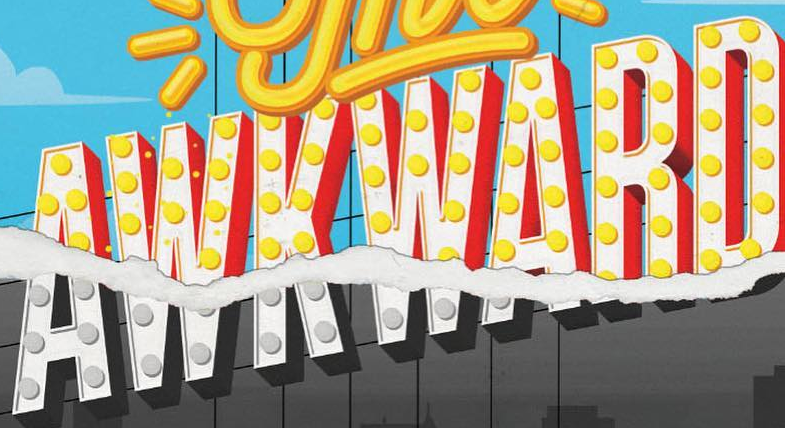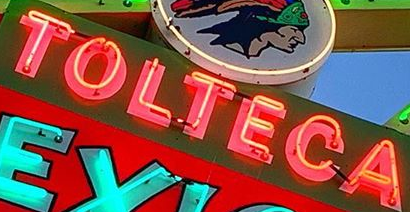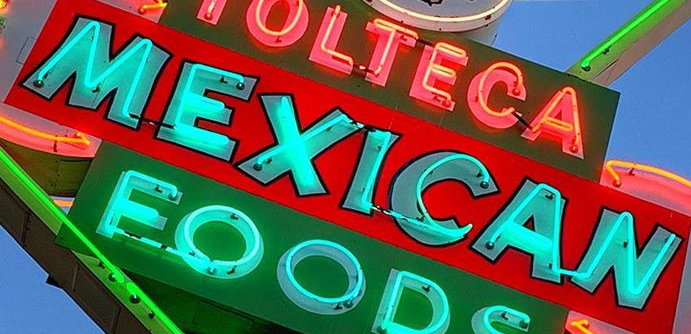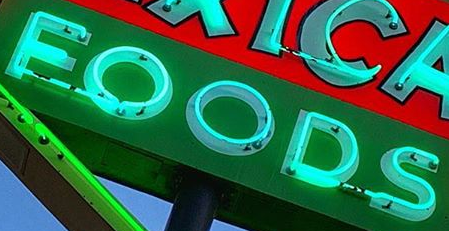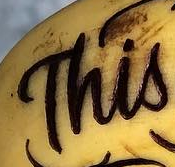What words are shown in these images in order, separated by a semicolon? AWKWARD; TOLTECA; MEXICAN; FOODS; This 